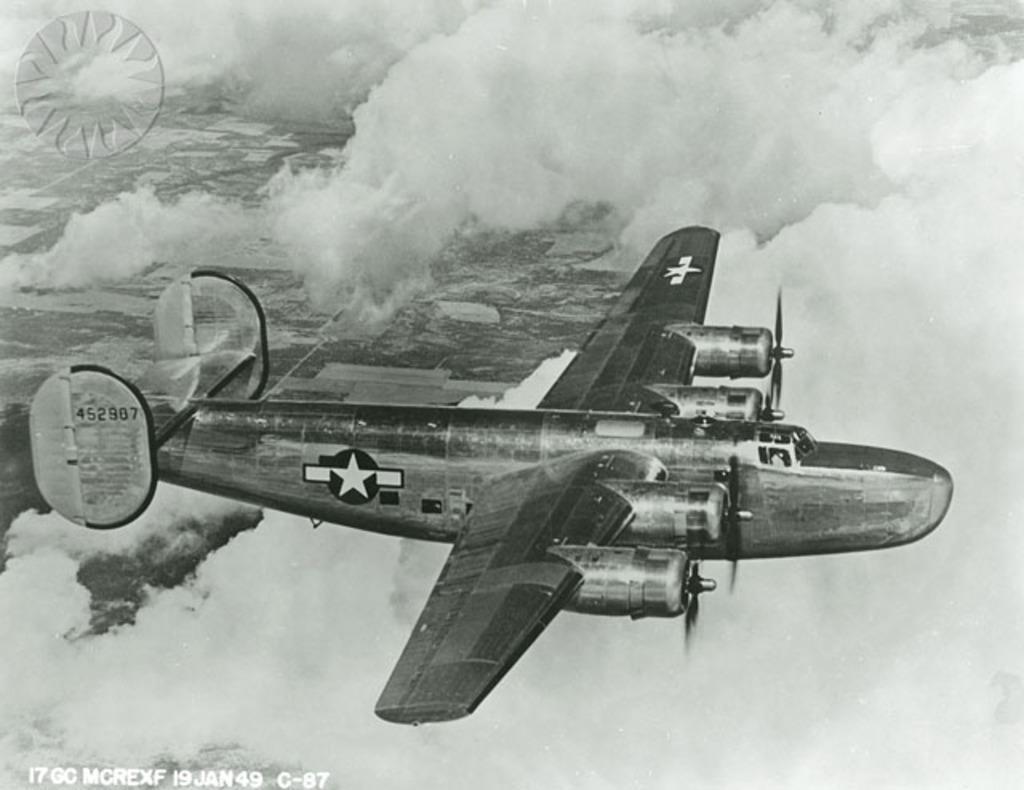Could you give a brief overview of what you see in this image? It is the black and white image in which we can see there is an airplane which is flying in the sky. There are clouds around it. 